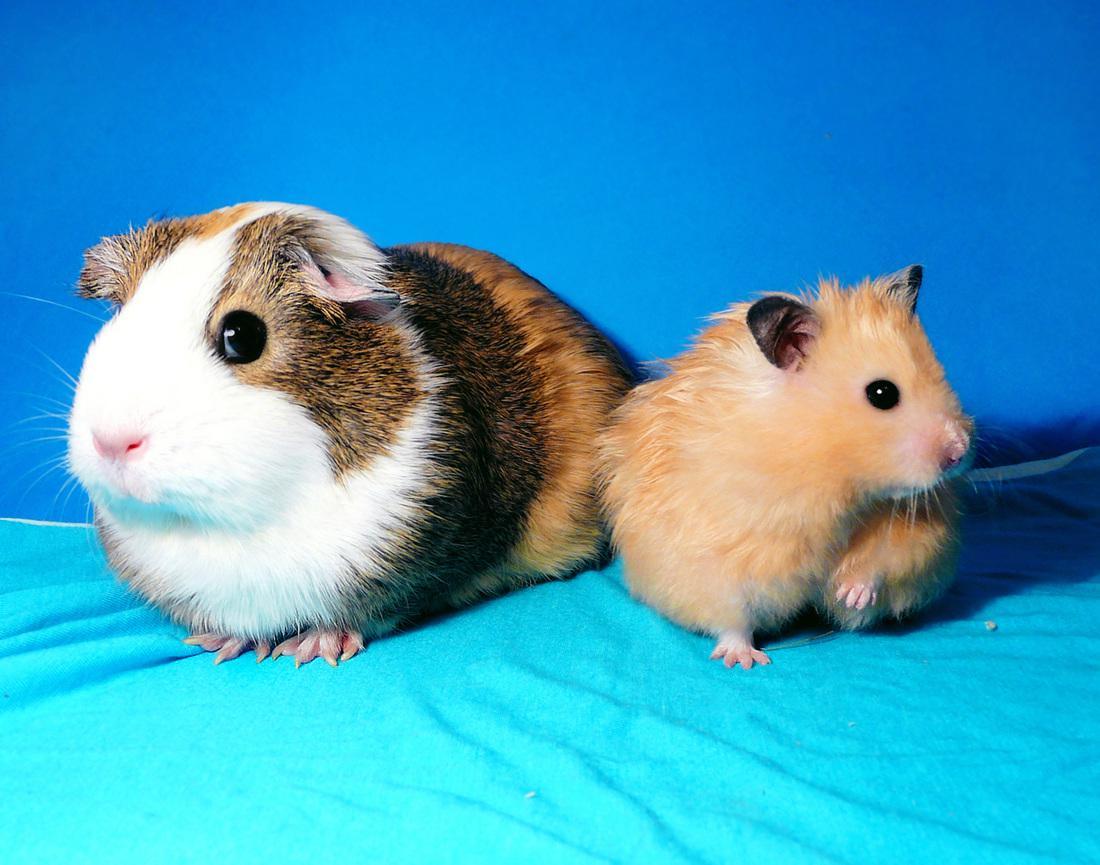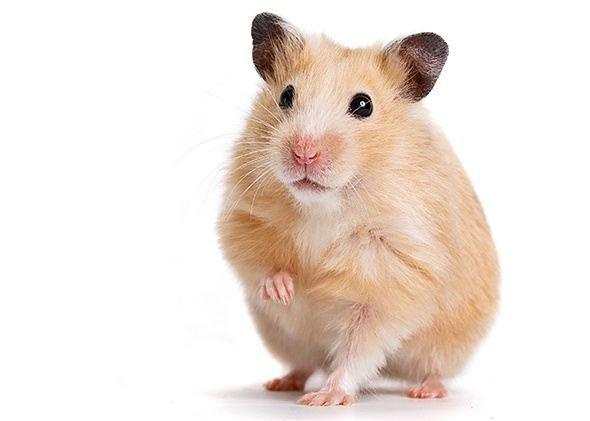The first image is the image on the left, the second image is the image on the right. Analyze the images presented: Is the assertion "The rodents in the image on the left are sitting on green grass." valid? Answer yes or no. No. The first image is the image on the left, the second image is the image on the right. For the images shown, is this caption "An image shows a larger guinea pig with a smaller pet rodent on a fabric ground surface." true? Answer yes or no. Yes. 